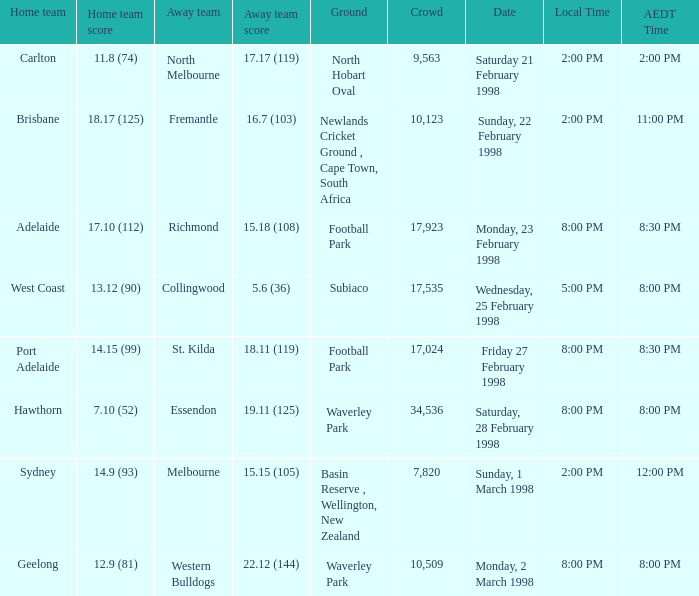What is the aedt time when the away team is collingwood? 8:00 PM. 